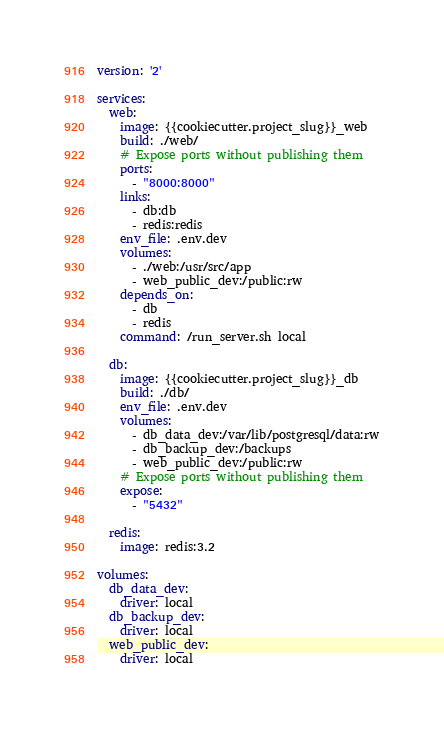<code> <loc_0><loc_0><loc_500><loc_500><_YAML_>version: '2'

services:
  web:
    image: {{cookiecutter.project_slug}}_web
    build: ./web/
    # Expose ports without publishing them
    ports:
      - "8000:8000"
    links:
      - db:db
      - redis:redis
    env_file: .env.dev
    volumes:
      - ./web:/usr/src/app
      - web_public_dev:/public:rw
    depends_on:
      - db
      - redis
    command: /run_server.sh local

  db:
    image: {{cookiecutter.project_slug}}_db
    build: ./db/
    env_file: .env.dev
    volumes:
      - db_data_dev:/var/lib/postgresql/data:rw
      - db_backup_dev:/backups
      - web_public_dev:/public:rw
    # Expose ports without publishing them
    expose:
      - "5432"

  redis:
    image: redis:3.2

volumes:
  db_data_dev:
    driver: local
  db_backup_dev:
    driver: local
  web_public_dev:
    driver: local</code> 